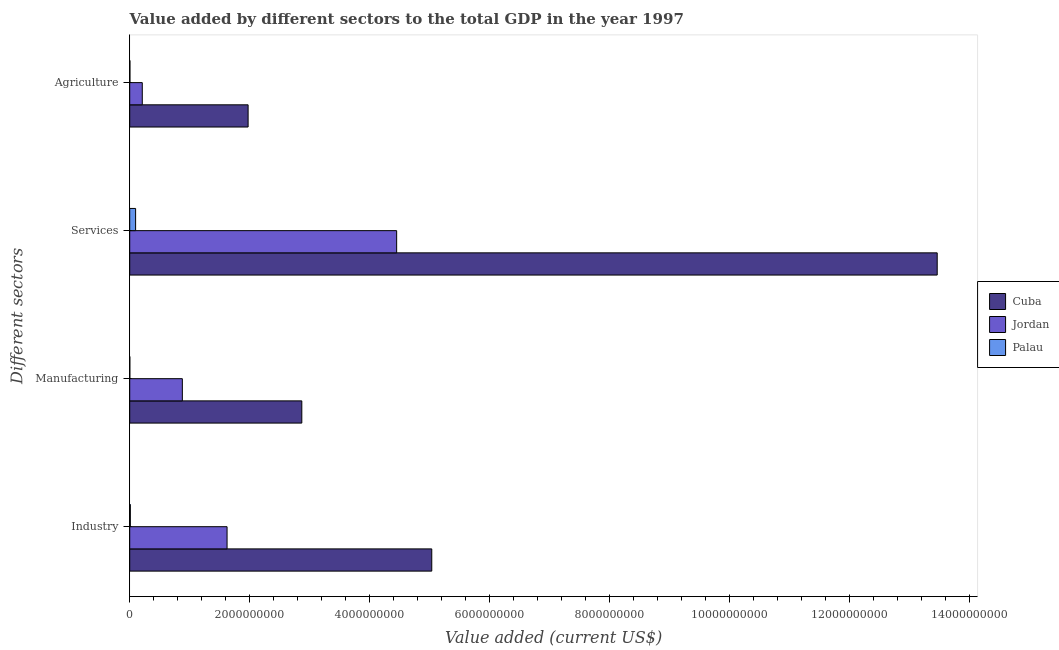How many groups of bars are there?
Your answer should be compact. 4. What is the label of the 4th group of bars from the top?
Make the answer very short. Industry. What is the value added by manufacturing sector in Palau?
Ensure brevity in your answer.  1.40e+06. Across all countries, what is the maximum value added by agricultural sector?
Provide a short and direct response. 1.97e+09. Across all countries, what is the minimum value added by services sector?
Your answer should be compact. 9.81e+07. In which country was the value added by industrial sector maximum?
Provide a short and direct response. Cuba. In which country was the value added by services sector minimum?
Your response must be concise. Palau. What is the total value added by agricultural sector in the graph?
Keep it short and to the point. 2.18e+09. What is the difference between the value added by services sector in Palau and that in Cuba?
Give a very brief answer. -1.34e+1. What is the difference between the value added by services sector in Jordan and the value added by manufacturing sector in Palau?
Your answer should be very brief. 4.45e+09. What is the average value added by agricultural sector per country?
Offer a terse response. 7.28e+08. What is the difference between the value added by manufacturing sector and value added by agricultural sector in Jordan?
Provide a short and direct response. 6.68e+08. What is the ratio of the value added by manufacturing sector in Palau to that in Cuba?
Ensure brevity in your answer.  0. Is the value added by agricultural sector in Palau less than that in Cuba?
Give a very brief answer. Yes. Is the difference between the value added by agricultural sector in Jordan and Cuba greater than the difference between the value added by manufacturing sector in Jordan and Cuba?
Your answer should be very brief. Yes. What is the difference between the highest and the second highest value added by services sector?
Offer a terse response. 9.01e+09. What is the difference between the highest and the lowest value added by industrial sector?
Ensure brevity in your answer.  5.02e+09. Is the sum of the value added by services sector in Cuba and Palau greater than the maximum value added by industrial sector across all countries?
Provide a succinct answer. Yes. What does the 1st bar from the top in Manufacturing represents?
Offer a terse response. Palau. What does the 2nd bar from the bottom in Services represents?
Provide a short and direct response. Jordan. Is it the case that in every country, the sum of the value added by industrial sector and value added by manufacturing sector is greater than the value added by services sector?
Give a very brief answer. No. How many bars are there?
Offer a terse response. 12. How many countries are there in the graph?
Your answer should be very brief. 3. What is the difference between two consecutive major ticks on the X-axis?
Provide a succinct answer. 2.00e+09. Does the graph contain grids?
Offer a very short reply. No. How are the legend labels stacked?
Your answer should be very brief. Vertical. What is the title of the graph?
Offer a very short reply. Value added by different sectors to the total GDP in the year 1997. Does "Honduras" appear as one of the legend labels in the graph?
Your response must be concise. No. What is the label or title of the X-axis?
Your response must be concise. Value added (current US$). What is the label or title of the Y-axis?
Your response must be concise. Different sectors. What is the Value added (current US$) in Cuba in Industry?
Ensure brevity in your answer.  5.03e+09. What is the Value added (current US$) of Jordan in Industry?
Keep it short and to the point. 1.62e+09. What is the Value added (current US$) of Palau in Industry?
Your response must be concise. 9.99e+06. What is the Value added (current US$) in Cuba in Manufacturing?
Your answer should be very brief. 2.87e+09. What is the Value added (current US$) of Jordan in Manufacturing?
Offer a very short reply. 8.77e+08. What is the Value added (current US$) in Palau in Manufacturing?
Make the answer very short. 1.40e+06. What is the Value added (current US$) of Cuba in Services?
Your answer should be very brief. 1.35e+1. What is the Value added (current US$) of Jordan in Services?
Provide a short and direct response. 4.45e+09. What is the Value added (current US$) of Palau in Services?
Ensure brevity in your answer.  9.81e+07. What is the Value added (current US$) in Cuba in Agriculture?
Make the answer very short. 1.97e+09. What is the Value added (current US$) of Jordan in Agriculture?
Keep it short and to the point. 2.09e+08. What is the Value added (current US$) in Palau in Agriculture?
Give a very brief answer. 3.37e+06. Across all Different sectors, what is the maximum Value added (current US$) of Cuba?
Offer a very short reply. 1.35e+1. Across all Different sectors, what is the maximum Value added (current US$) in Jordan?
Your answer should be very brief. 4.45e+09. Across all Different sectors, what is the maximum Value added (current US$) of Palau?
Ensure brevity in your answer.  9.81e+07. Across all Different sectors, what is the minimum Value added (current US$) in Cuba?
Make the answer very short. 1.97e+09. Across all Different sectors, what is the minimum Value added (current US$) in Jordan?
Make the answer very short. 2.09e+08. Across all Different sectors, what is the minimum Value added (current US$) in Palau?
Keep it short and to the point. 1.40e+06. What is the total Value added (current US$) of Cuba in the graph?
Your response must be concise. 2.33e+1. What is the total Value added (current US$) in Jordan in the graph?
Offer a terse response. 7.16e+09. What is the total Value added (current US$) in Palau in the graph?
Offer a terse response. 1.13e+08. What is the difference between the Value added (current US$) of Cuba in Industry and that in Manufacturing?
Keep it short and to the point. 2.17e+09. What is the difference between the Value added (current US$) of Jordan in Industry and that in Manufacturing?
Your answer should be compact. 7.45e+08. What is the difference between the Value added (current US$) of Palau in Industry and that in Manufacturing?
Make the answer very short. 8.58e+06. What is the difference between the Value added (current US$) in Cuba in Industry and that in Services?
Provide a short and direct response. -8.42e+09. What is the difference between the Value added (current US$) of Jordan in Industry and that in Services?
Keep it short and to the point. -2.83e+09. What is the difference between the Value added (current US$) in Palau in Industry and that in Services?
Provide a short and direct response. -8.81e+07. What is the difference between the Value added (current US$) of Cuba in Industry and that in Agriculture?
Your answer should be very brief. 3.06e+09. What is the difference between the Value added (current US$) in Jordan in Industry and that in Agriculture?
Your answer should be compact. 1.41e+09. What is the difference between the Value added (current US$) of Palau in Industry and that in Agriculture?
Offer a very short reply. 6.62e+06. What is the difference between the Value added (current US$) in Cuba in Manufacturing and that in Services?
Provide a succinct answer. -1.06e+1. What is the difference between the Value added (current US$) of Jordan in Manufacturing and that in Services?
Keep it short and to the point. -3.57e+09. What is the difference between the Value added (current US$) of Palau in Manufacturing and that in Services?
Give a very brief answer. -9.67e+07. What is the difference between the Value added (current US$) in Cuba in Manufacturing and that in Agriculture?
Provide a short and direct response. 8.95e+08. What is the difference between the Value added (current US$) of Jordan in Manufacturing and that in Agriculture?
Your response must be concise. 6.68e+08. What is the difference between the Value added (current US$) in Palau in Manufacturing and that in Agriculture?
Provide a succinct answer. -1.97e+06. What is the difference between the Value added (current US$) in Cuba in Services and that in Agriculture?
Keep it short and to the point. 1.15e+1. What is the difference between the Value added (current US$) in Jordan in Services and that in Agriculture?
Your response must be concise. 4.24e+09. What is the difference between the Value added (current US$) of Palau in Services and that in Agriculture?
Your response must be concise. 9.47e+07. What is the difference between the Value added (current US$) in Cuba in Industry and the Value added (current US$) in Jordan in Manufacturing?
Give a very brief answer. 4.16e+09. What is the difference between the Value added (current US$) of Cuba in Industry and the Value added (current US$) of Palau in Manufacturing?
Your answer should be compact. 5.03e+09. What is the difference between the Value added (current US$) of Jordan in Industry and the Value added (current US$) of Palau in Manufacturing?
Provide a succinct answer. 1.62e+09. What is the difference between the Value added (current US$) of Cuba in Industry and the Value added (current US$) of Jordan in Services?
Offer a very short reply. 5.85e+08. What is the difference between the Value added (current US$) of Cuba in Industry and the Value added (current US$) of Palau in Services?
Your response must be concise. 4.93e+09. What is the difference between the Value added (current US$) in Jordan in Industry and the Value added (current US$) in Palau in Services?
Provide a succinct answer. 1.52e+09. What is the difference between the Value added (current US$) of Cuba in Industry and the Value added (current US$) of Jordan in Agriculture?
Give a very brief answer. 4.82e+09. What is the difference between the Value added (current US$) in Cuba in Industry and the Value added (current US$) in Palau in Agriculture?
Give a very brief answer. 5.03e+09. What is the difference between the Value added (current US$) of Jordan in Industry and the Value added (current US$) of Palau in Agriculture?
Give a very brief answer. 1.62e+09. What is the difference between the Value added (current US$) of Cuba in Manufacturing and the Value added (current US$) of Jordan in Services?
Provide a succinct answer. -1.58e+09. What is the difference between the Value added (current US$) of Cuba in Manufacturing and the Value added (current US$) of Palau in Services?
Make the answer very short. 2.77e+09. What is the difference between the Value added (current US$) in Jordan in Manufacturing and the Value added (current US$) in Palau in Services?
Ensure brevity in your answer.  7.79e+08. What is the difference between the Value added (current US$) of Cuba in Manufacturing and the Value added (current US$) of Jordan in Agriculture?
Ensure brevity in your answer.  2.66e+09. What is the difference between the Value added (current US$) in Cuba in Manufacturing and the Value added (current US$) in Palau in Agriculture?
Offer a very short reply. 2.86e+09. What is the difference between the Value added (current US$) of Jordan in Manufacturing and the Value added (current US$) of Palau in Agriculture?
Your response must be concise. 8.73e+08. What is the difference between the Value added (current US$) of Cuba in Services and the Value added (current US$) of Jordan in Agriculture?
Provide a succinct answer. 1.32e+1. What is the difference between the Value added (current US$) in Cuba in Services and the Value added (current US$) in Palau in Agriculture?
Your answer should be very brief. 1.35e+1. What is the difference between the Value added (current US$) of Jordan in Services and the Value added (current US$) of Palau in Agriculture?
Your answer should be very brief. 4.44e+09. What is the average Value added (current US$) of Cuba per Different sectors?
Provide a short and direct response. 5.83e+09. What is the average Value added (current US$) of Jordan per Different sectors?
Give a very brief answer. 1.79e+09. What is the average Value added (current US$) in Palau per Different sectors?
Provide a succinct answer. 2.82e+07. What is the difference between the Value added (current US$) of Cuba and Value added (current US$) of Jordan in Industry?
Provide a short and direct response. 3.41e+09. What is the difference between the Value added (current US$) of Cuba and Value added (current US$) of Palau in Industry?
Offer a very short reply. 5.02e+09. What is the difference between the Value added (current US$) in Jordan and Value added (current US$) in Palau in Industry?
Keep it short and to the point. 1.61e+09. What is the difference between the Value added (current US$) in Cuba and Value added (current US$) in Jordan in Manufacturing?
Give a very brief answer. 1.99e+09. What is the difference between the Value added (current US$) of Cuba and Value added (current US$) of Palau in Manufacturing?
Your answer should be compact. 2.87e+09. What is the difference between the Value added (current US$) of Jordan and Value added (current US$) of Palau in Manufacturing?
Your answer should be compact. 8.75e+08. What is the difference between the Value added (current US$) in Cuba and Value added (current US$) in Jordan in Services?
Provide a succinct answer. 9.01e+09. What is the difference between the Value added (current US$) in Cuba and Value added (current US$) in Palau in Services?
Provide a succinct answer. 1.34e+1. What is the difference between the Value added (current US$) of Jordan and Value added (current US$) of Palau in Services?
Your response must be concise. 4.35e+09. What is the difference between the Value added (current US$) of Cuba and Value added (current US$) of Jordan in Agriculture?
Give a very brief answer. 1.76e+09. What is the difference between the Value added (current US$) of Cuba and Value added (current US$) of Palau in Agriculture?
Your response must be concise. 1.97e+09. What is the difference between the Value added (current US$) of Jordan and Value added (current US$) of Palau in Agriculture?
Make the answer very short. 2.06e+08. What is the ratio of the Value added (current US$) of Cuba in Industry to that in Manufacturing?
Give a very brief answer. 1.76. What is the ratio of the Value added (current US$) of Jordan in Industry to that in Manufacturing?
Ensure brevity in your answer.  1.85. What is the ratio of the Value added (current US$) of Palau in Industry to that in Manufacturing?
Your answer should be very brief. 7.12. What is the ratio of the Value added (current US$) of Cuba in Industry to that in Services?
Ensure brevity in your answer.  0.37. What is the ratio of the Value added (current US$) in Jordan in Industry to that in Services?
Your response must be concise. 0.36. What is the ratio of the Value added (current US$) of Palau in Industry to that in Services?
Provide a short and direct response. 0.1. What is the ratio of the Value added (current US$) in Cuba in Industry to that in Agriculture?
Keep it short and to the point. 2.55. What is the ratio of the Value added (current US$) of Jordan in Industry to that in Agriculture?
Make the answer very short. 7.75. What is the ratio of the Value added (current US$) of Palau in Industry to that in Agriculture?
Your response must be concise. 2.96. What is the ratio of the Value added (current US$) in Cuba in Manufacturing to that in Services?
Provide a short and direct response. 0.21. What is the ratio of the Value added (current US$) in Jordan in Manufacturing to that in Services?
Keep it short and to the point. 0.2. What is the ratio of the Value added (current US$) of Palau in Manufacturing to that in Services?
Ensure brevity in your answer.  0.01. What is the ratio of the Value added (current US$) in Cuba in Manufacturing to that in Agriculture?
Make the answer very short. 1.45. What is the ratio of the Value added (current US$) in Jordan in Manufacturing to that in Agriculture?
Your answer should be compact. 4.19. What is the ratio of the Value added (current US$) in Palau in Manufacturing to that in Agriculture?
Ensure brevity in your answer.  0.42. What is the ratio of the Value added (current US$) in Cuba in Services to that in Agriculture?
Offer a terse response. 6.82. What is the ratio of the Value added (current US$) of Jordan in Services to that in Agriculture?
Give a very brief answer. 21.26. What is the ratio of the Value added (current US$) of Palau in Services to that in Agriculture?
Make the answer very short. 29.12. What is the difference between the highest and the second highest Value added (current US$) of Cuba?
Ensure brevity in your answer.  8.42e+09. What is the difference between the highest and the second highest Value added (current US$) in Jordan?
Provide a short and direct response. 2.83e+09. What is the difference between the highest and the second highest Value added (current US$) in Palau?
Provide a succinct answer. 8.81e+07. What is the difference between the highest and the lowest Value added (current US$) of Cuba?
Your answer should be very brief. 1.15e+1. What is the difference between the highest and the lowest Value added (current US$) of Jordan?
Provide a short and direct response. 4.24e+09. What is the difference between the highest and the lowest Value added (current US$) in Palau?
Ensure brevity in your answer.  9.67e+07. 